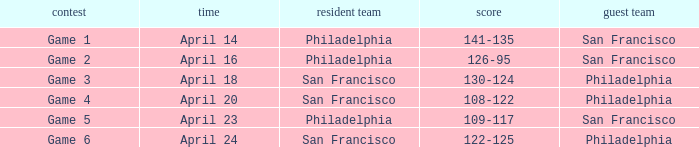Which games had Philadelphia as home team? Game 1, Game 2, Game 5. 